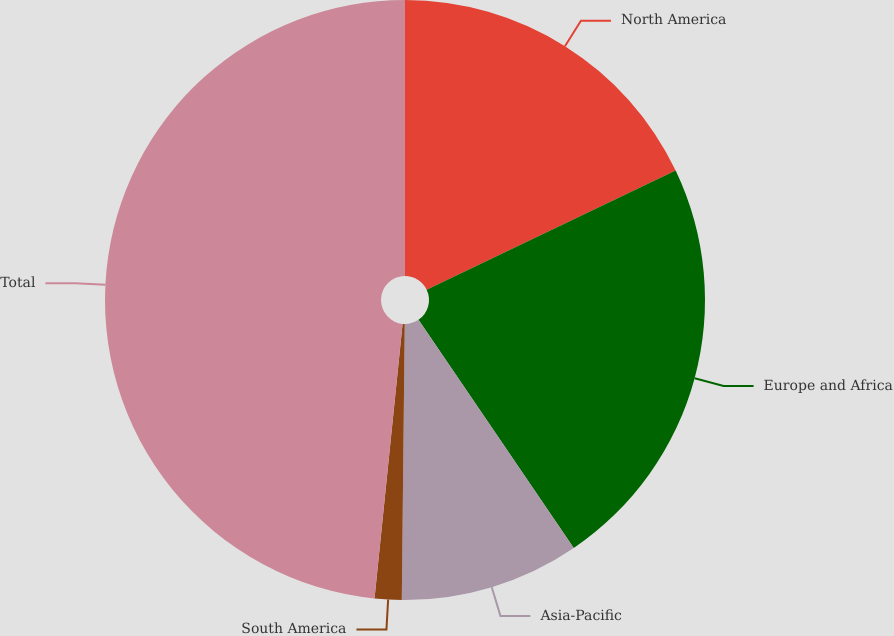Convert chart. <chart><loc_0><loc_0><loc_500><loc_500><pie_chart><fcel>North America<fcel>Europe and Africa<fcel>Asia-Pacific<fcel>South America<fcel>Total<nl><fcel>17.9%<fcel>22.59%<fcel>9.68%<fcel>1.45%<fcel>48.38%<nl></chart> 